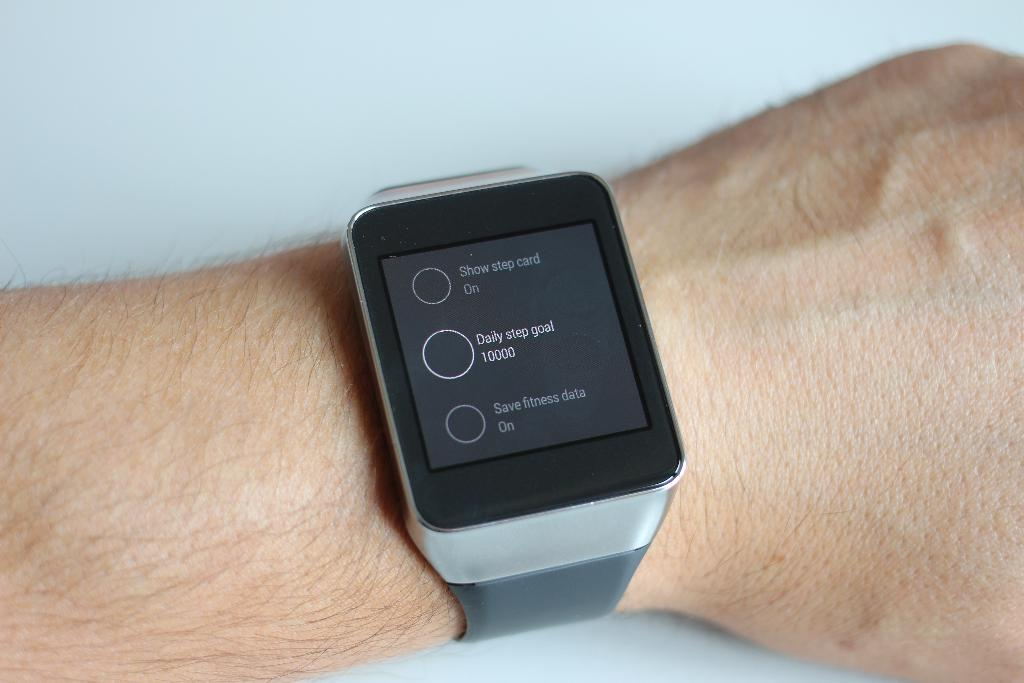<image>
Describe the image concisely. arm with watch on it that is showing the daily step goal is 10000 